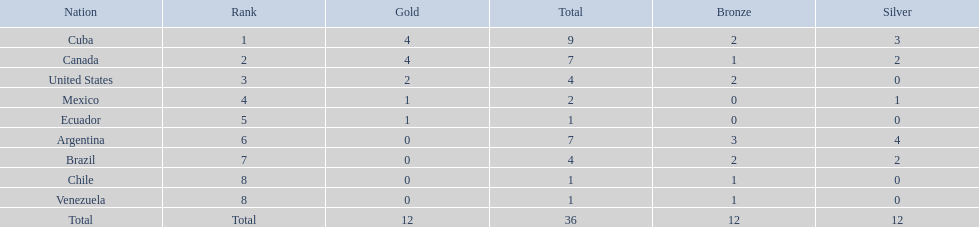What were all of the nations involved in the canoeing at the 2011 pan american games? Cuba, Canada, United States, Mexico, Ecuador, Argentina, Brazil, Chile, Venezuela, Total. Of these, which had a numbered rank? Cuba, Canada, United States, Mexico, Ecuador, Argentina, Brazil, Chile, Venezuela. From these, which had the highest number of bronze? Argentina. 